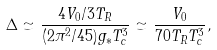Convert formula to latex. <formula><loc_0><loc_0><loc_500><loc_500>\Delta \simeq \frac { 4 V _ { 0 } / 3 T _ { R } } { ( 2 \pi ^ { 2 } / 4 5 ) g _ { * } T _ { c } ^ { 3 } } \simeq \frac { V _ { 0 } } { 7 0 T _ { R } T _ { c } ^ { 3 } } ,</formula> 